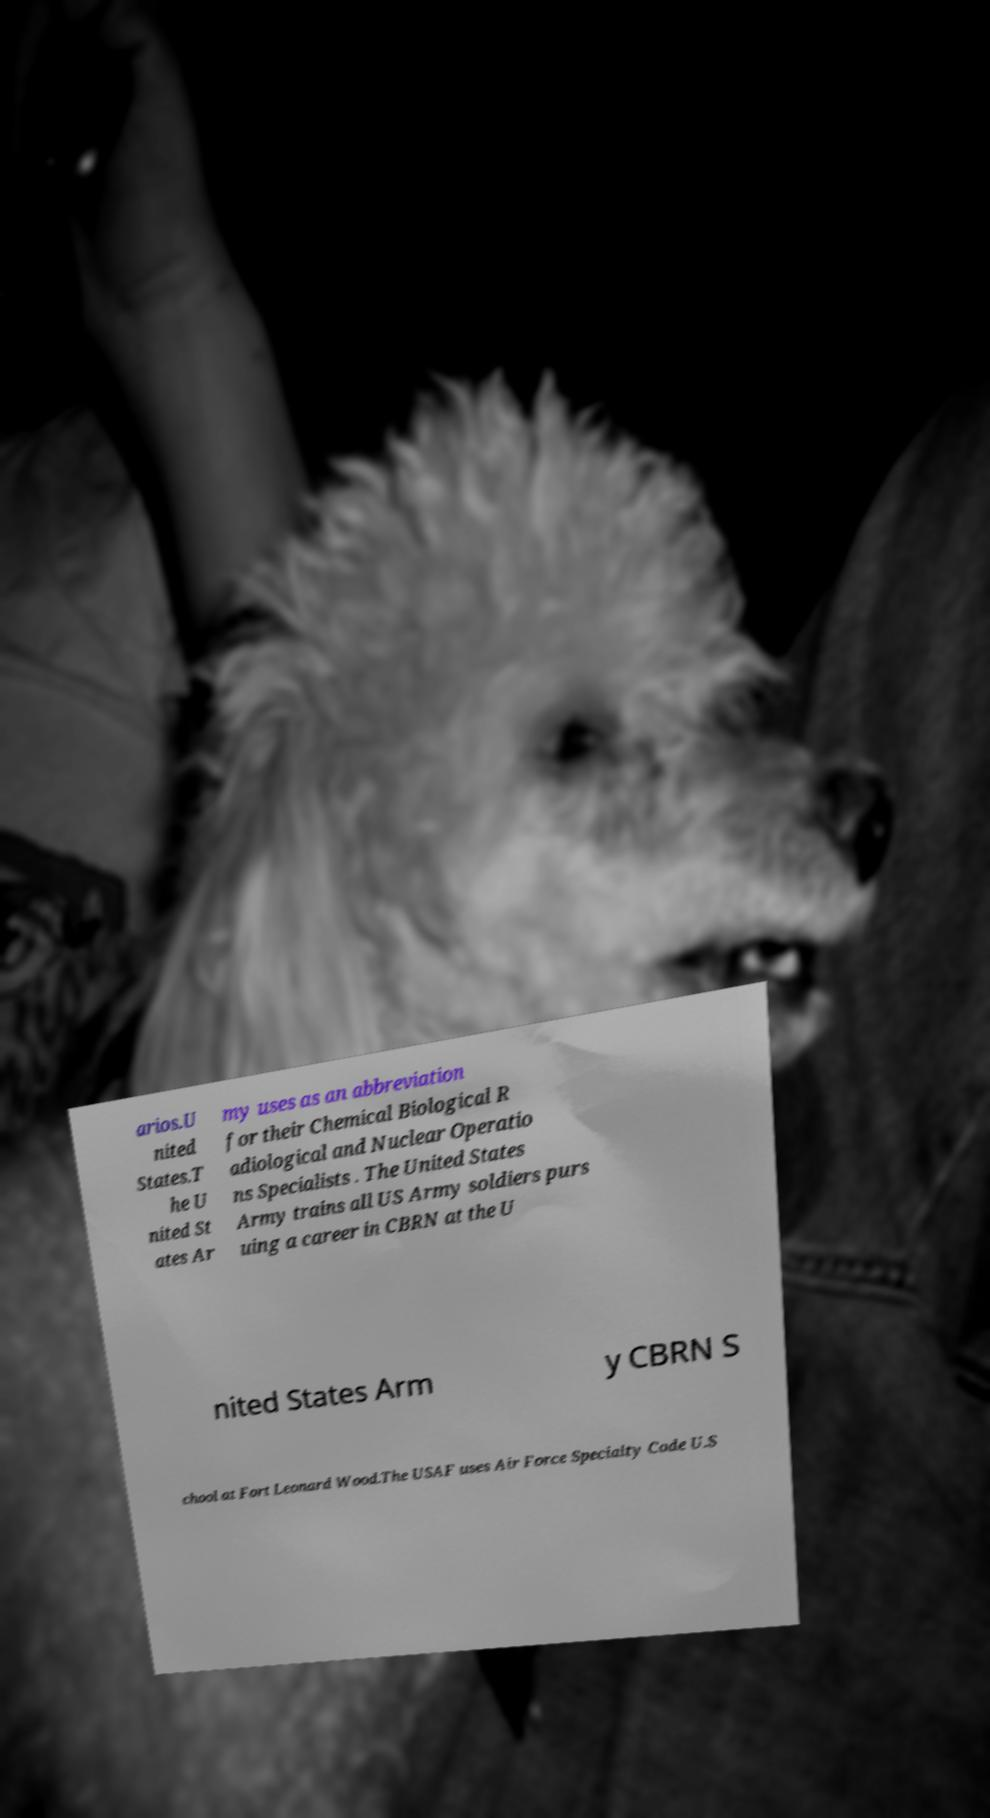What messages or text are displayed in this image? I need them in a readable, typed format. arios.U nited States.T he U nited St ates Ar my uses as an abbreviation for their Chemical Biological R adiological and Nuclear Operatio ns Specialists . The United States Army trains all US Army soldiers purs uing a career in CBRN at the U nited States Arm y CBRN S chool at Fort Leonard Wood.The USAF uses Air Force Specialty Code U.S 